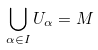<formula> <loc_0><loc_0><loc_500><loc_500>\bigcup _ { \alpha \in I } U _ { \alpha } = M</formula> 